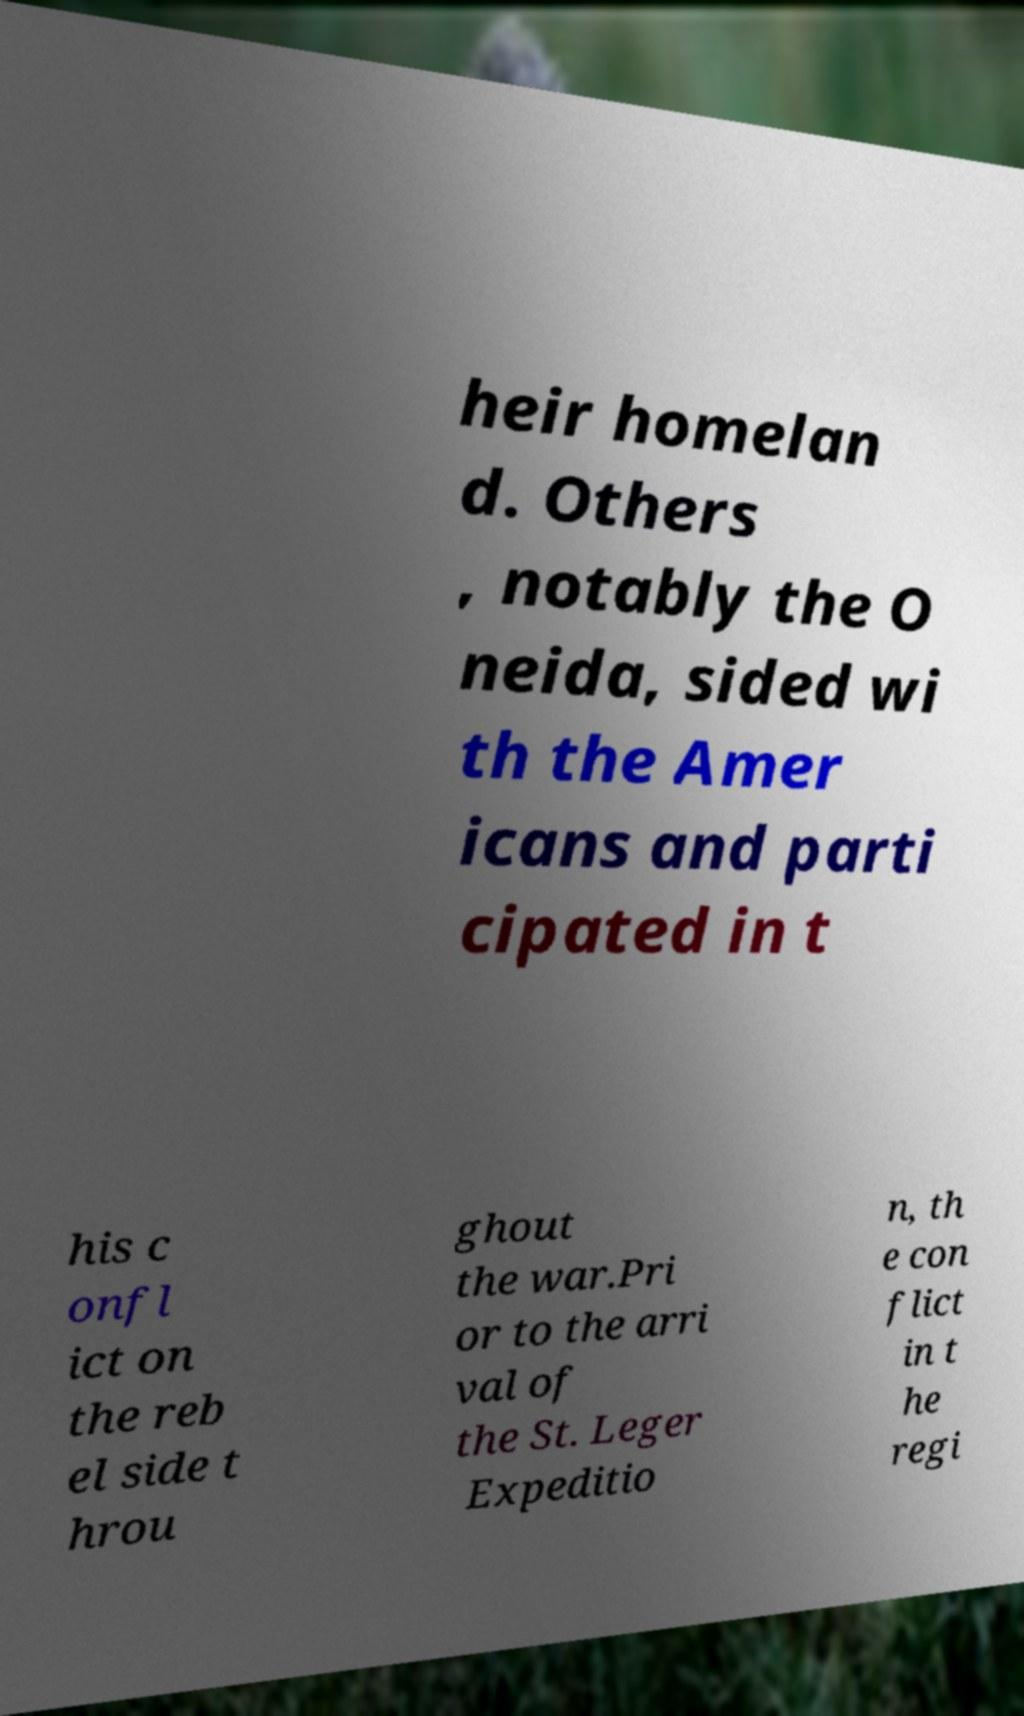Can you read and provide the text displayed in the image?This photo seems to have some interesting text. Can you extract and type it out for me? heir homelan d. Others , notably the O neida, sided wi th the Amer icans and parti cipated in t his c onfl ict on the reb el side t hrou ghout the war.Pri or to the arri val of the St. Leger Expeditio n, th e con flict in t he regi 